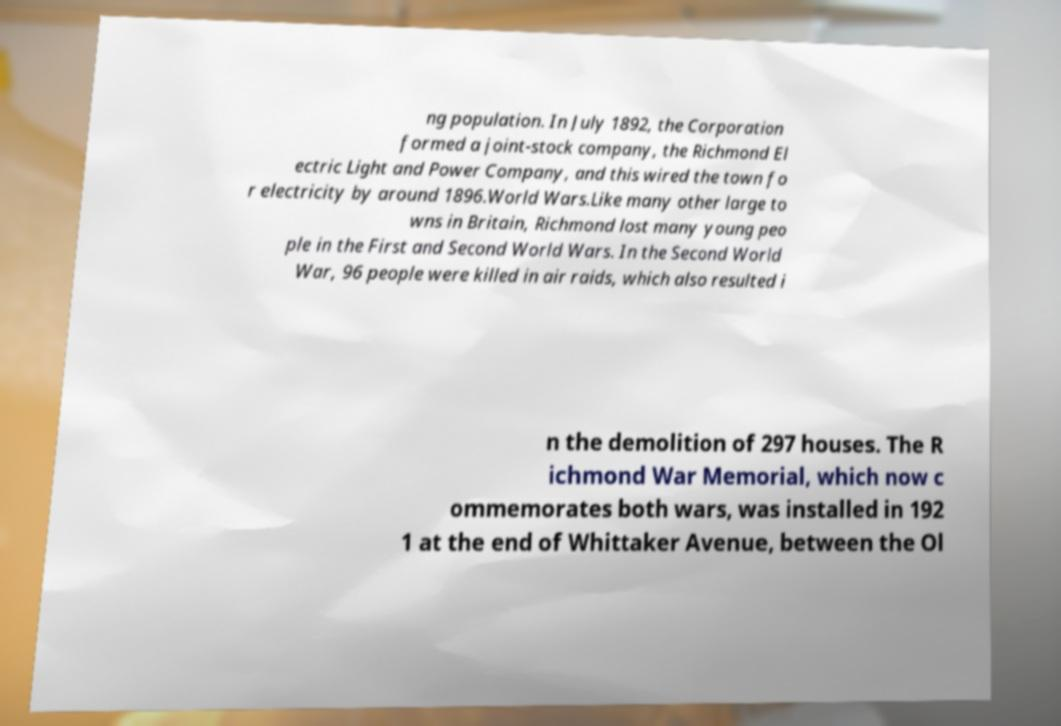Could you assist in decoding the text presented in this image and type it out clearly? ng population. In July 1892, the Corporation formed a joint-stock company, the Richmond El ectric Light and Power Company, and this wired the town fo r electricity by around 1896.World Wars.Like many other large to wns in Britain, Richmond lost many young peo ple in the First and Second World Wars. In the Second World War, 96 people were killed in air raids, which also resulted i n the demolition of 297 houses. The R ichmond War Memorial, which now c ommemorates both wars, was installed in 192 1 at the end of Whittaker Avenue, between the Ol 